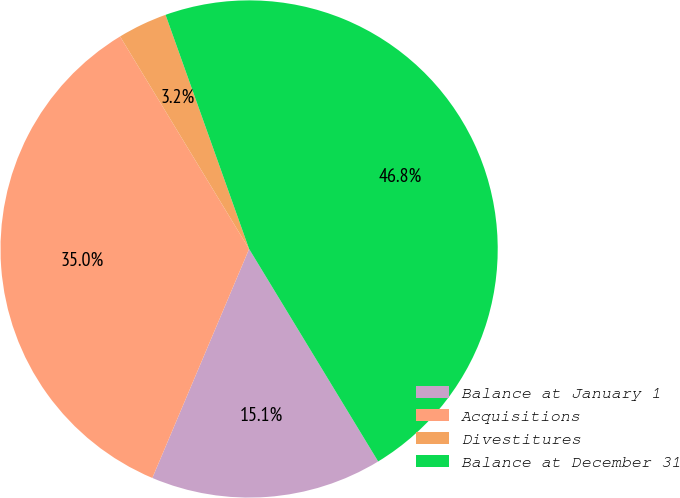Convert chart to OTSL. <chart><loc_0><loc_0><loc_500><loc_500><pie_chart><fcel>Balance at January 1<fcel>Acquisitions<fcel>Divestitures<fcel>Balance at December 31<nl><fcel>15.05%<fcel>34.95%<fcel>3.23%<fcel>46.77%<nl></chart> 